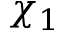<formula> <loc_0><loc_0><loc_500><loc_500>\chi _ { 1 }</formula> 